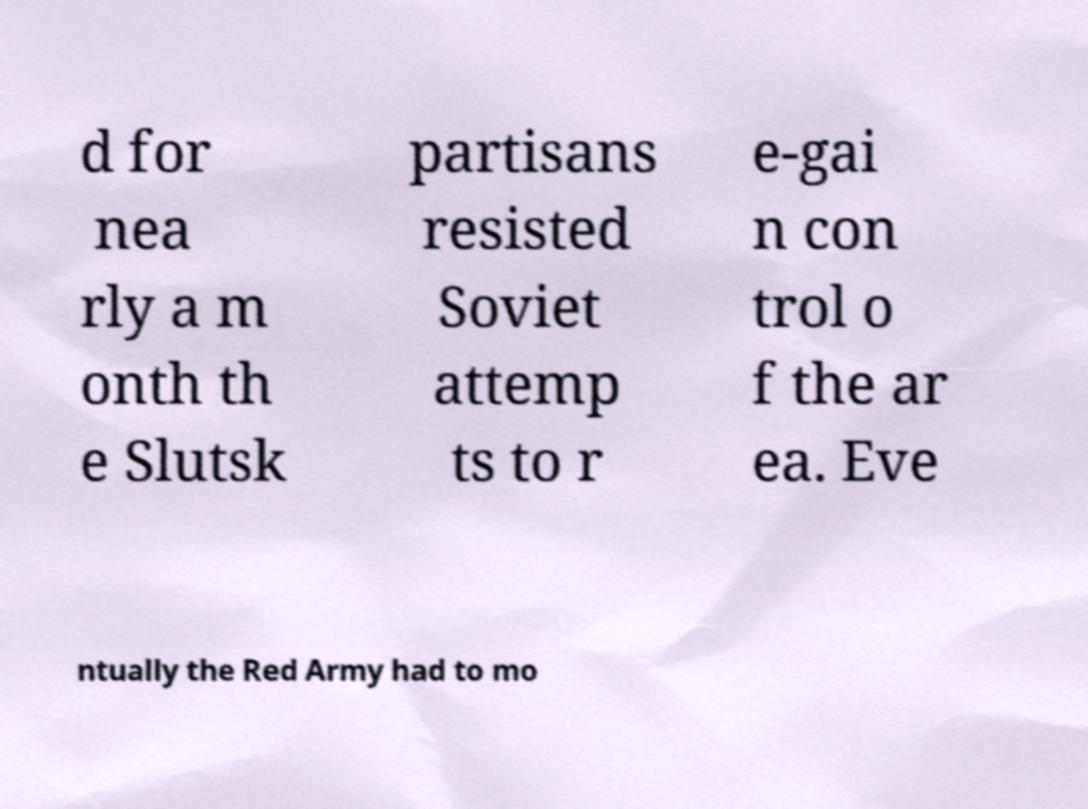There's text embedded in this image that I need extracted. Can you transcribe it verbatim? d for nea rly a m onth th e Slutsk partisans resisted Soviet attemp ts to r e-gai n con trol o f the ar ea. Eve ntually the Red Army had to mo 